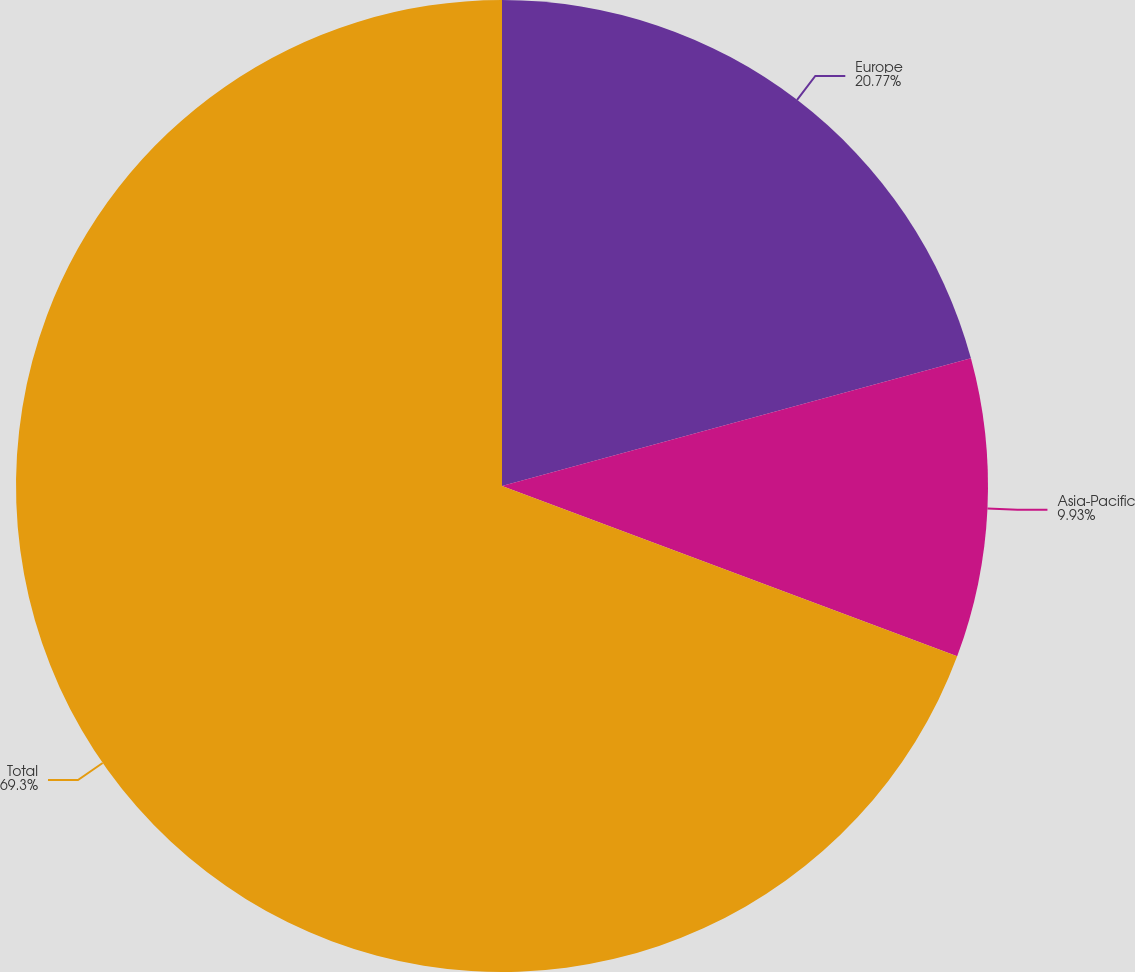Convert chart. <chart><loc_0><loc_0><loc_500><loc_500><pie_chart><fcel>Europe<fcel>Asia-Pacific<fcel>Total<nl><fcel>20.77%<fcel>9.93%<fcel>69.3%<nl></chart> 